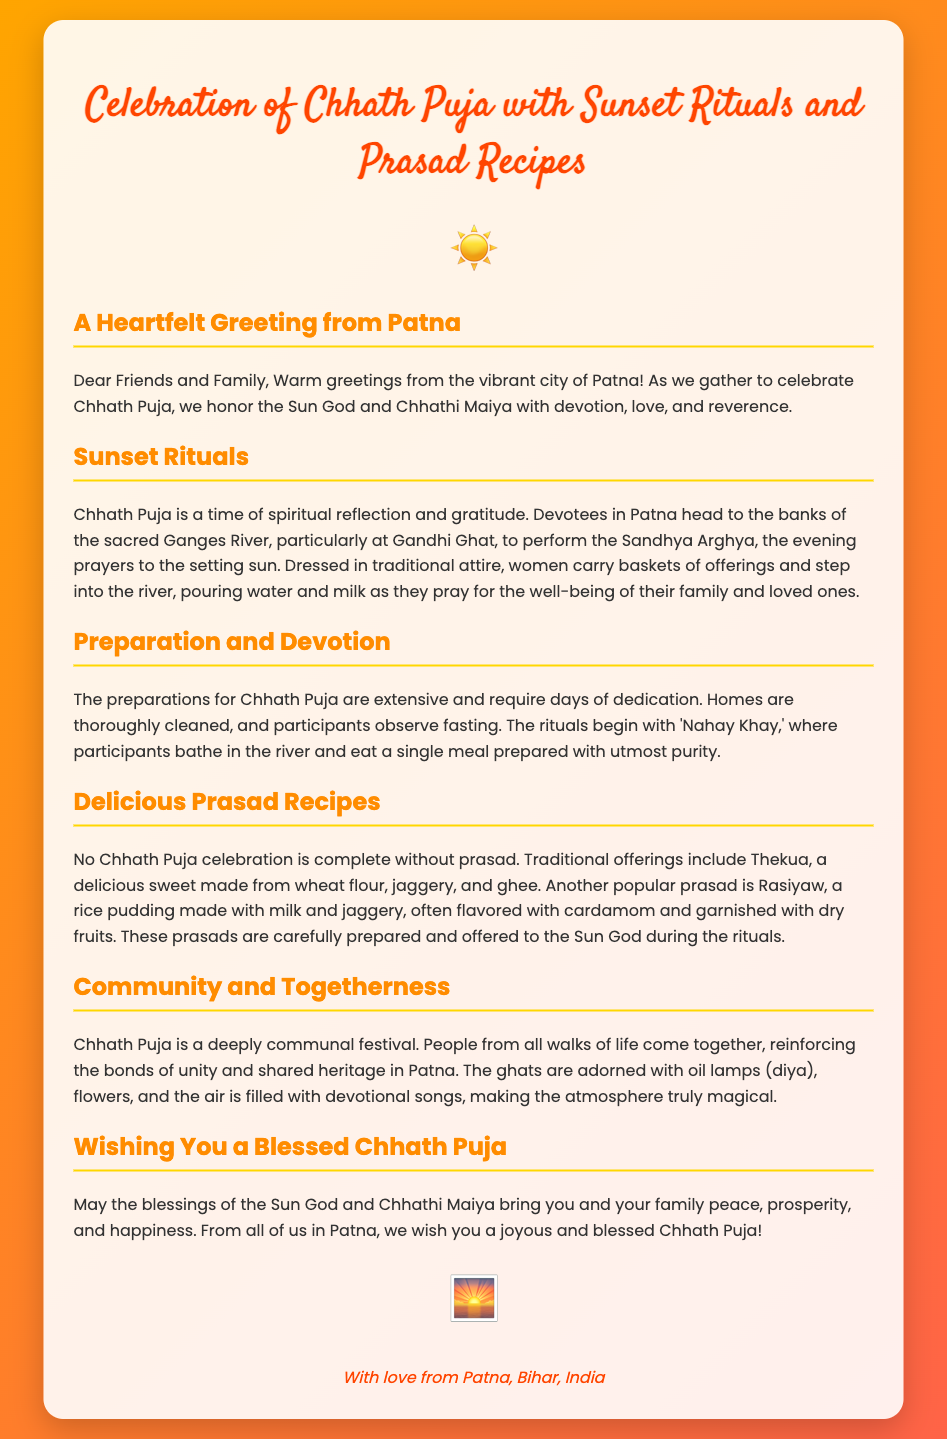What is the title of the greeting card? The title of the greeting card is mentioned prominently at the top of the document.
Answer: Celebration of Chhath Puja with Sunset Rituals and Prasad Recipes What is the location mentioned for performing the Sandhya Arghya? The document specifies the location where devotees gather for the rituals.
Answer: Ganges River, particularly at Gandhi Ghat What two traditional prasads are mentioned? The document lists the prasads that are offered during Chhath Puja.
Answer: Thekua and Rasiyaw What is the greeting card's purpose? The overall aim of the greeting card is clearly stated in its content.
Answer: To wish a blessed Chhath Puja What do participants observe before the rituals begin? The document mentions a specific practice that participants engage in prior to the rituals.
Answer: Fasting How does Chhath Puja promote community? The card discusses the aspects of community involvement during the festival.
Answer: Reinforces bonds of unity and shared heritage What do women carry during the Sandhya Arghya? The document describes items that women take with them during the sunset rituals.
Answer: Baskets of offerings What symbolic blessings are wished for in the card? The card mentions the type of blessings that are hoped for during Chhath Puja.
Answer: Peace, prosperity, and happiness 